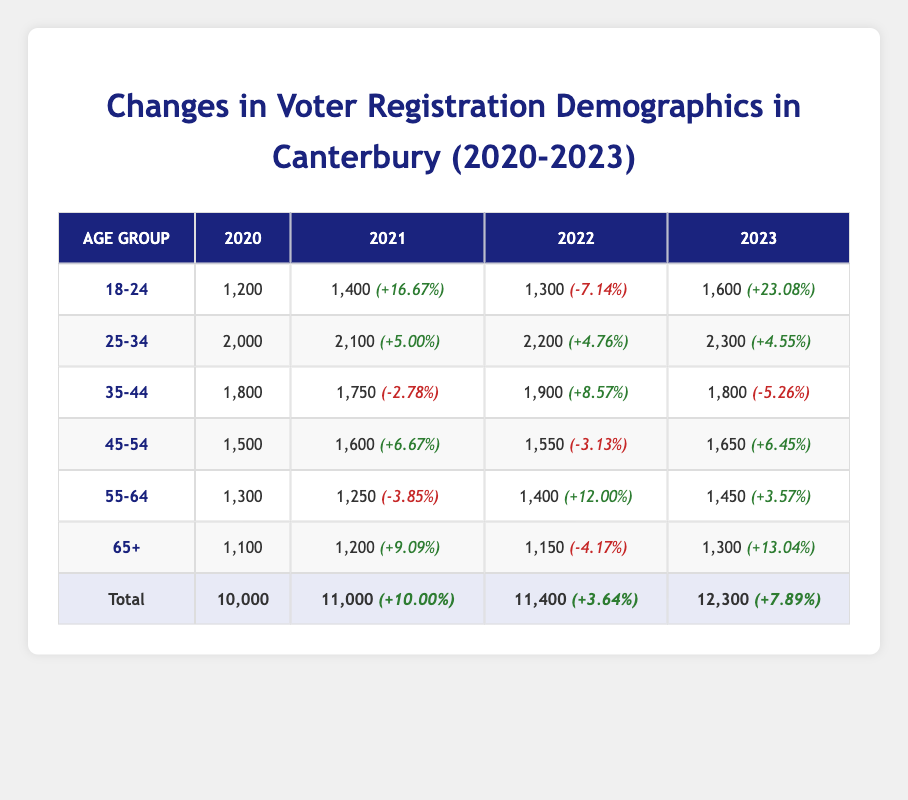What was the total number of registered voters in Canterbury in 2023? The table shows that the total number of registered voters for the year 2023 is 12,300.
Answer: 12,300 Which age group saw the highest percentage increase in registered voters from 2022 to 2023? By checking the Percentage Change column for the year 2023, the 18-24 age group shows a +23.08% increase, which is the highest.
Answer: 18-24 What was the total voter registration in 2020 and 2021? The total voter registration in 2020 was 10,000, and in 2021 it was 11,000. Adding these gives 10,000 + 11,000 = 21,000.
Answer: 21,000 Did the 35-44 age group experience a positive percentage change in any year? Looking at the Percentage Change for the 35-44 age group, the years 2021 and 2023 show negative changes (-2.78% and -5.26%), and only 2022 shows a positive change (+8.57%). Therefore, yes, there was a positive change in 2022.
Answer: Yes What was the percentage change for the 55-64 age group from 2022 to 2023? The 55-64 age group's percentage change from 2022 to 2023 is +3.57%, as indicated in the table.
Answer: +3.57% Which age group had the lowest total registrations in 2020? Looking at the Total Registered column for 2020, the age group 65+ has the lowest total registrations with 1,100.
Answer: 65+ How many more voters were registered in 2021 compared to 2020? The number of registered voters increased from 10,000 in 2020 to 11,000 in 2021. The difference is 11,000 - 10,000 = 1,000.
Answer: 1,000 Was the overall percentage change in voter registrations positive in every year? Checking the Overall Percentage Change, in 2020 the change is null, in 2021 it is +10.00%, 2022 it is +3.64% and in 2023 it is +7.89%. Therefore, no, it was not positive in 2020.
Answer: No How many registered voters aged 45-54 were there in 2022? Referring to the Total Registered column for the 45-54 age group in 2022, there were 1,550 registered voters.
Answer: 1,550 What is the average number of total registrations for the years 2021 to 2023? The total registrations for 2021, 2022, and 2023 are 11,000, 11,400, and 12,300 respectively. The sum is 11,000 + 11,400 + 12,300 = 34,700. Dividing by 3 gives an average of 34,700 / 3 = 11,566.67.
Answer: 11,566.67 What was the most frequent percentage change for the age group 25-34 over the years? The age group 25-34 had percentage changes of +5.00%, +4.76%, and +4.55%. All percentage changes are positive and closest to each other, making these percentage changes most frequent in being positive, but they differ in value.
Answer: All positive changes 